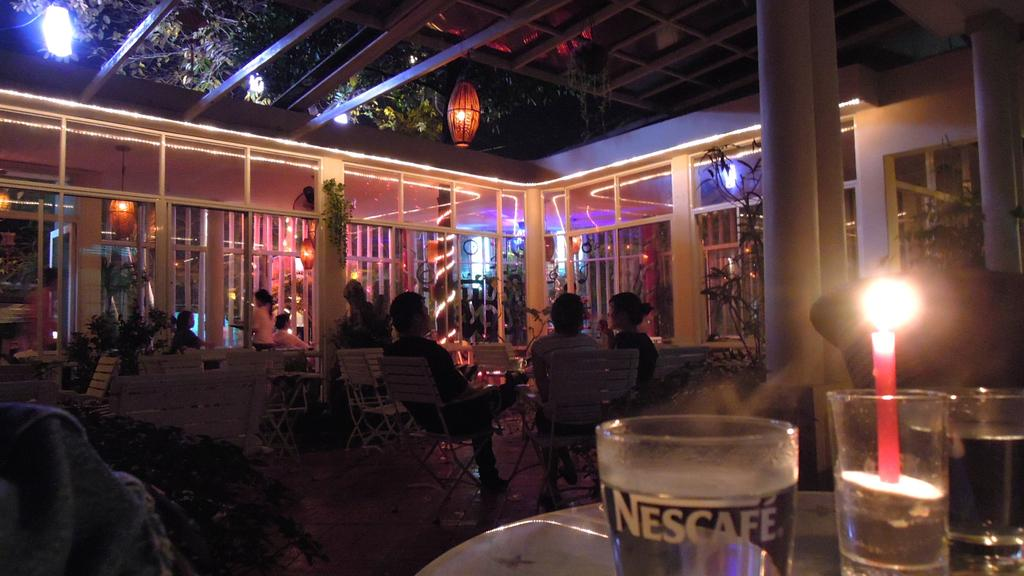<image>
Describe the image concisely. People are sitting in chairs in an outdoor lounge and a class says Nescafe. 